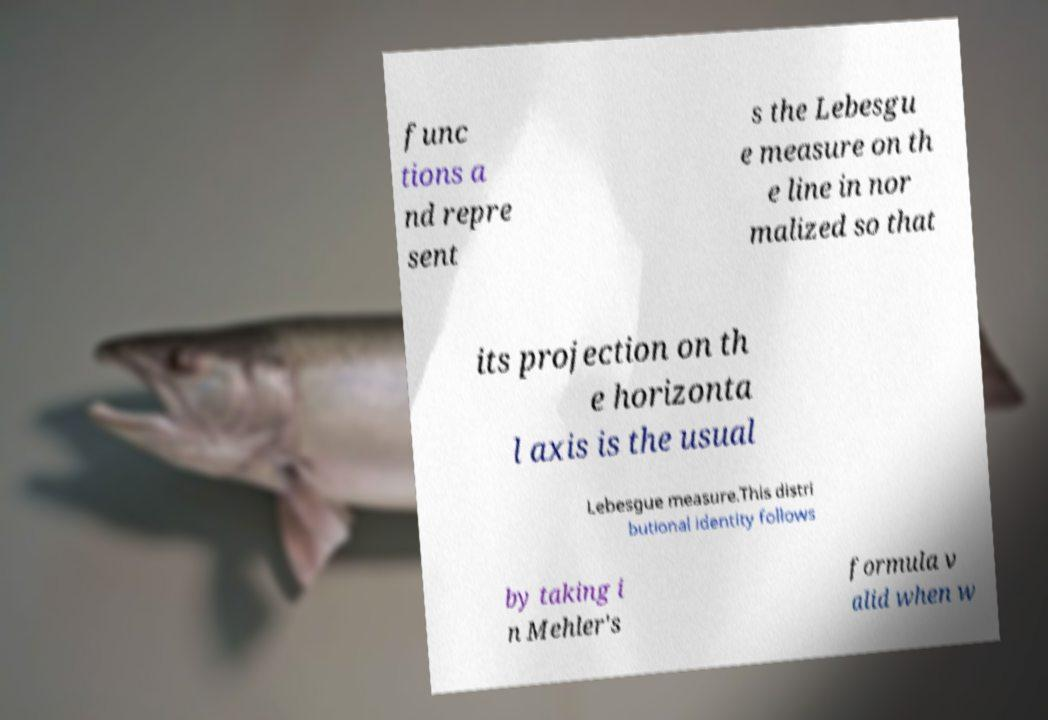For documentation purposes, I need the text within this image transcribed. Could you provide that? func tions a nd repre sent s the Lebesgu e measure on th e line in nor malized so that its projection on th e horizonta l axis is the usual Lebesgue measure.This distri butional identity follows by taking i n Mehler's formula v alid when w 